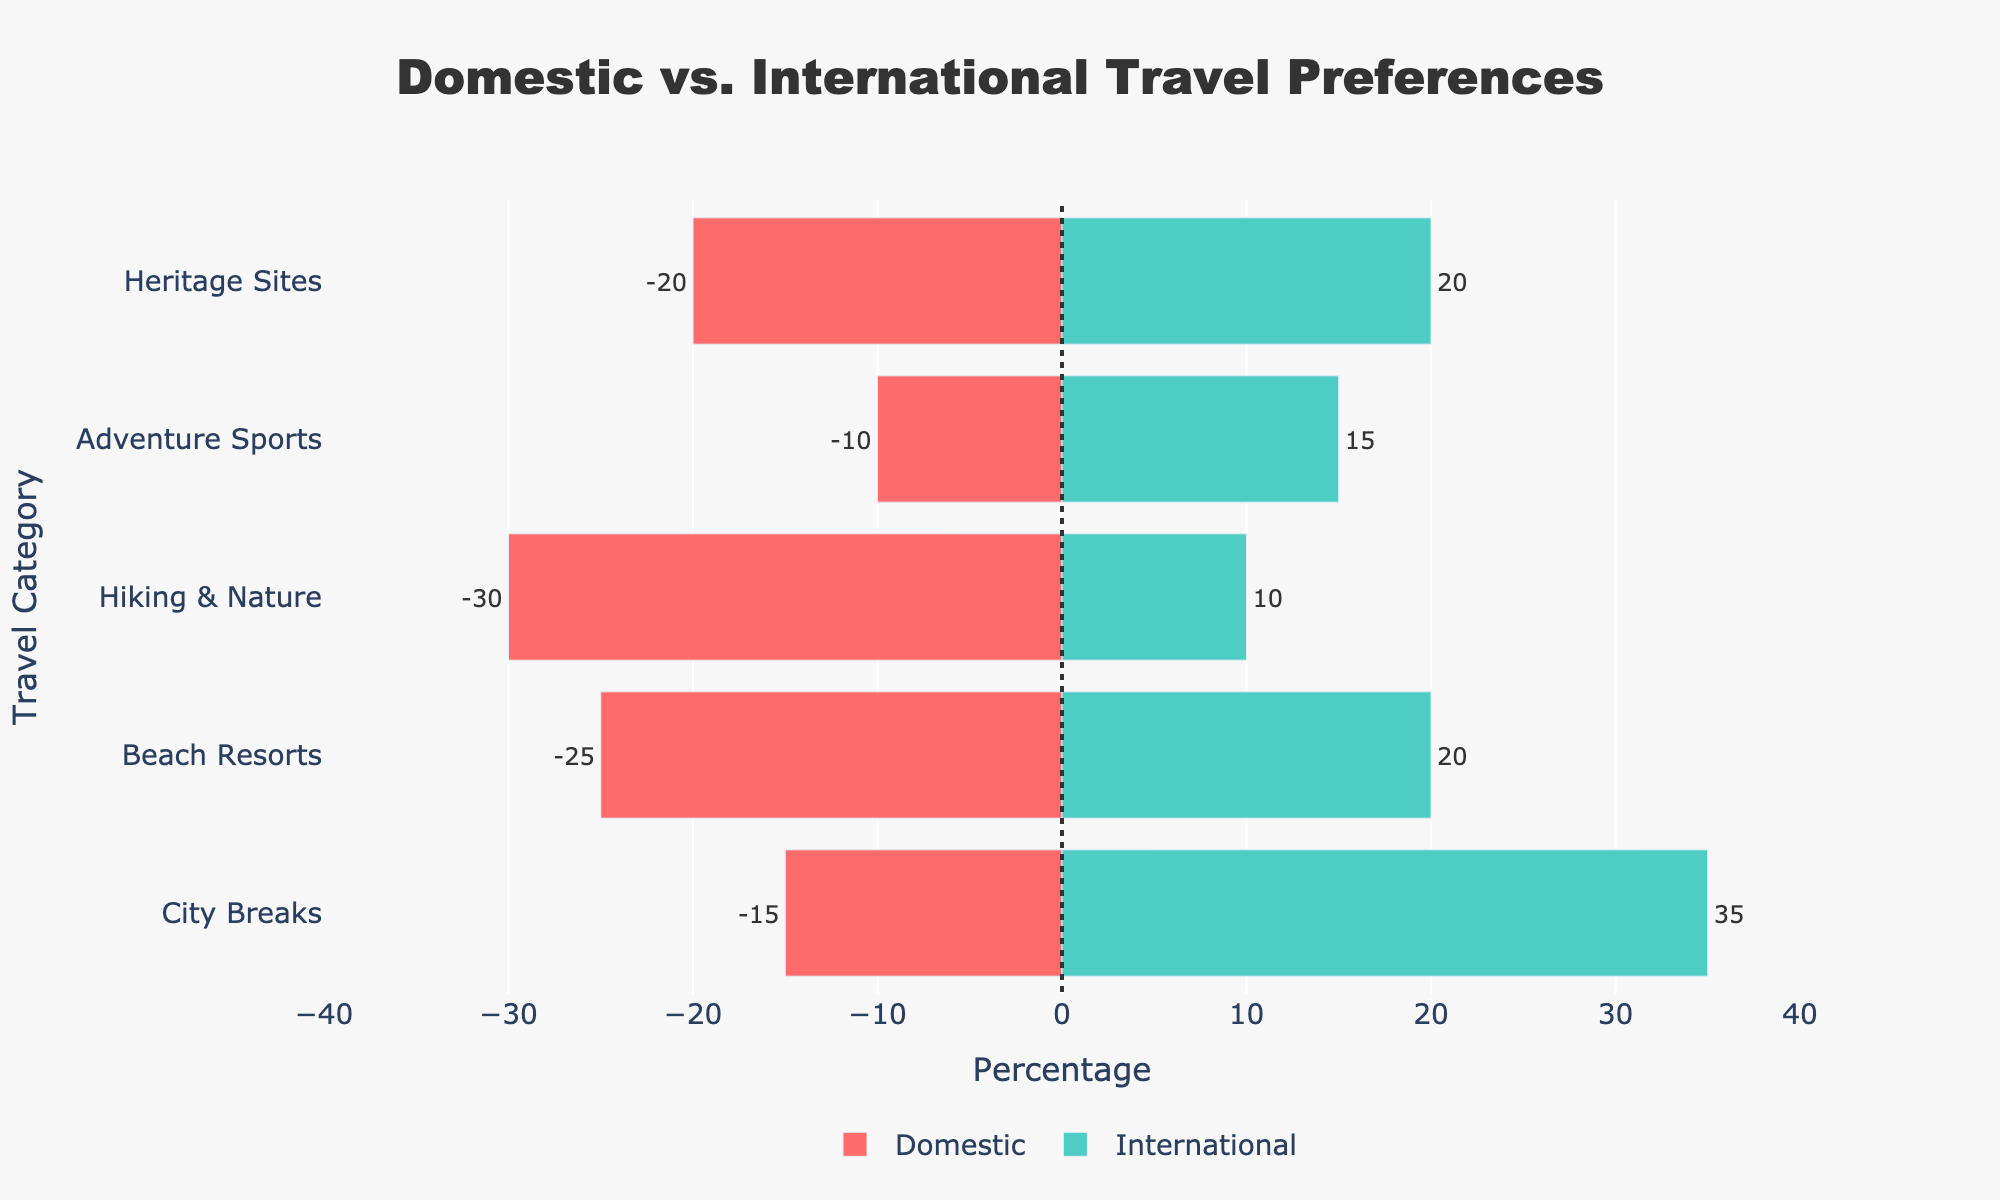What's the most preferred travel category domestically? Looking at the red bars representing domestic travel, "Hiking & Nature" has the longest bar extending to -30%, indicating it's the most preferred.
Answer: Hiking & Nature What percentage of travelers prefer international city breaks? Referring to the green bars for international travel, the "City Breaks" bar extends to 35%, indicating that 35% of international travelers prefer city breaks.
Answer: 35% How much more popular are domestic beach resorts compared to international beach resorts? The red bar for domestic beach resorts extends to -25%, while the green bar for international extends to 20%. The difference in preference is 25% - 20% = 5%.
Answer: 5% What is the least preferred travel category domestically? Among the red bars for domestic travel, "Adventure Sports" has the shortest bar extending to -10%, indicating it is the least preferred domestically.
Answer: Adventure Sports Compare the preference for heritage sites between domestic and international travelers. Both red and green bars for "Heritage Sites" extend to 20%, indicating equal preference among domestic and international travelers.
Answer: Equal What is the combined preference percentage for domestic city breaks and heritage sites? The red bar for city breaks is -15%, and for heritage sites, it's -20%. The combined preference is 15% + 20% = 35%.
Answer: 35% Is hiking & nature more favored domestically or internationally? By how much? The red bar for domestic hiking & nature extends to -30%, and the green bar for international extends to 10%. So, domestically it is more favored by 30% - 10% = 20%.
Answer: Domestically, by 20% Which travel category has the least disparity between domestic and international preferences? The "Heritage Sites" bars (both red and green) are equal at 20%, showing the least disparity.
Answer: Heritage Sites, 0% What is the difference in percentage between domestic and international adventure sports trips? The red bar for domestic adventure sports is -10%, and the green bar for international is 15%. The difference is 15% - 10% = 5%.
Answer: 5% Which category has a stronger preference when comparing both domestic and international trips between city breaks and beach resorts? The red bar for Domestic City Breaks is -15% and for Beach Resorts is -25%; the green bar for International City Breaks is 35% and for Beach Resorts is 20%. Comparing sums: City Breaks (15% + 35% = 50%), Beach Resorts (25% + 20% = 45%). Thus, City Breaks have a stronger overall preference.
Answer: City Breaks 